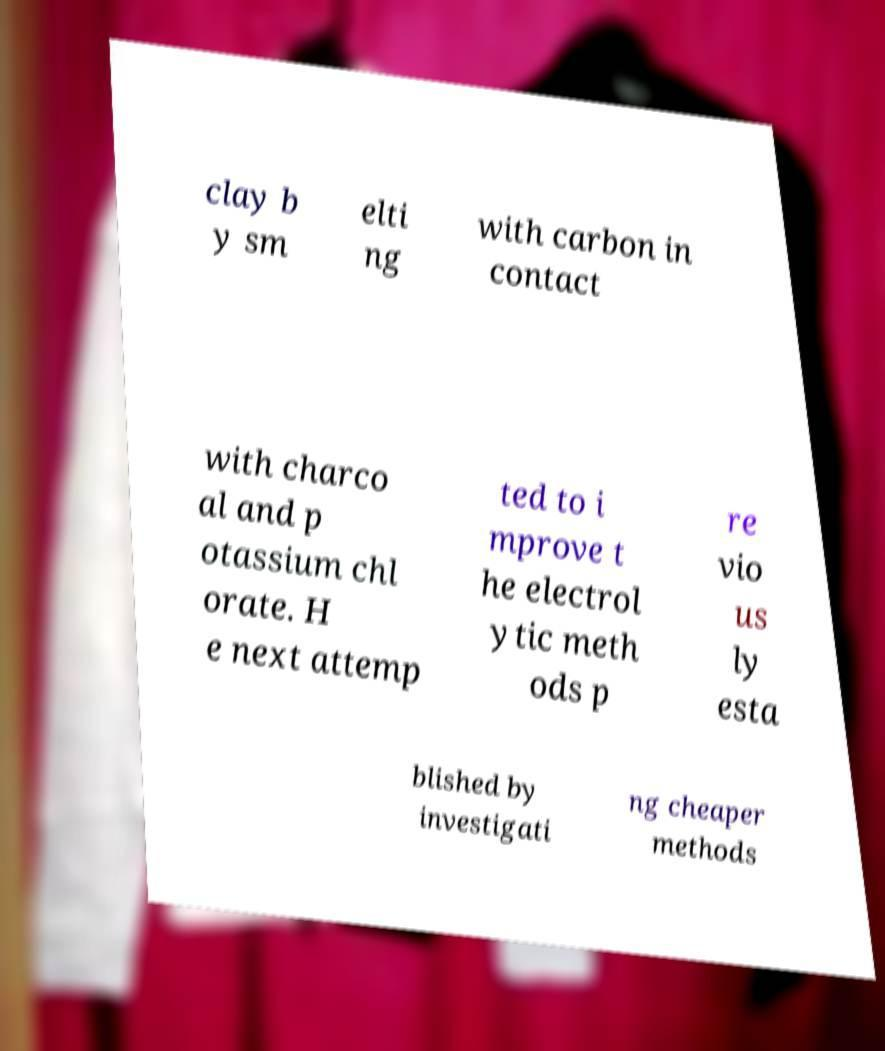There's text embedded in this image that I need extracted. Can you transcribe it verbatim? clay b y sm elti ng with carbon in contact with charco al and p otassium chl orate. H e next attemp ted to i mprove t he electrol ytic meth ods p re vio us ly esta blished by investigati ng cheaper methods 